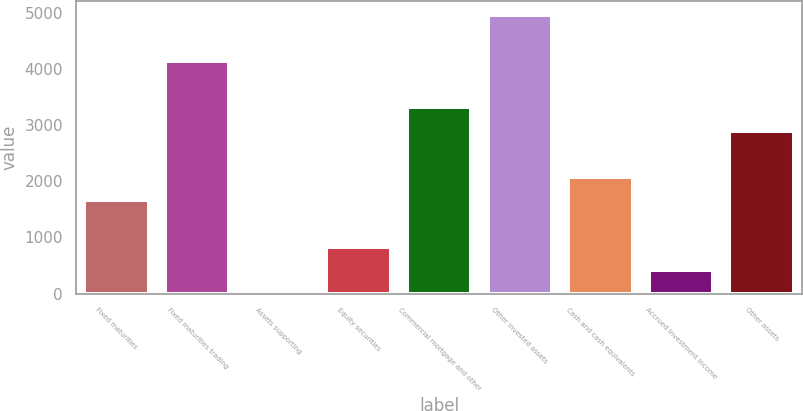Convert chart. <chart><loc_0><loc_0><loc_500><loc_500><bar_chart><fcel>Fixed maturities<fcel>Fixed maturities trading<fcel>Assets supporting<fcel>Equity securities<fcel>Commercial mortgage and other<fcel>Other invested assets<fcel>Cash and cash equivalents<fcel>Accrued investment income<fcel>Other assets<nl><fcel>1658.4<fcel>4140<fcel>4<fcel>831.2<fcel>3312.8<fcel>4967.2<fcel>2072<fcel>417.6<fcel>2899.2<nl></chart> 